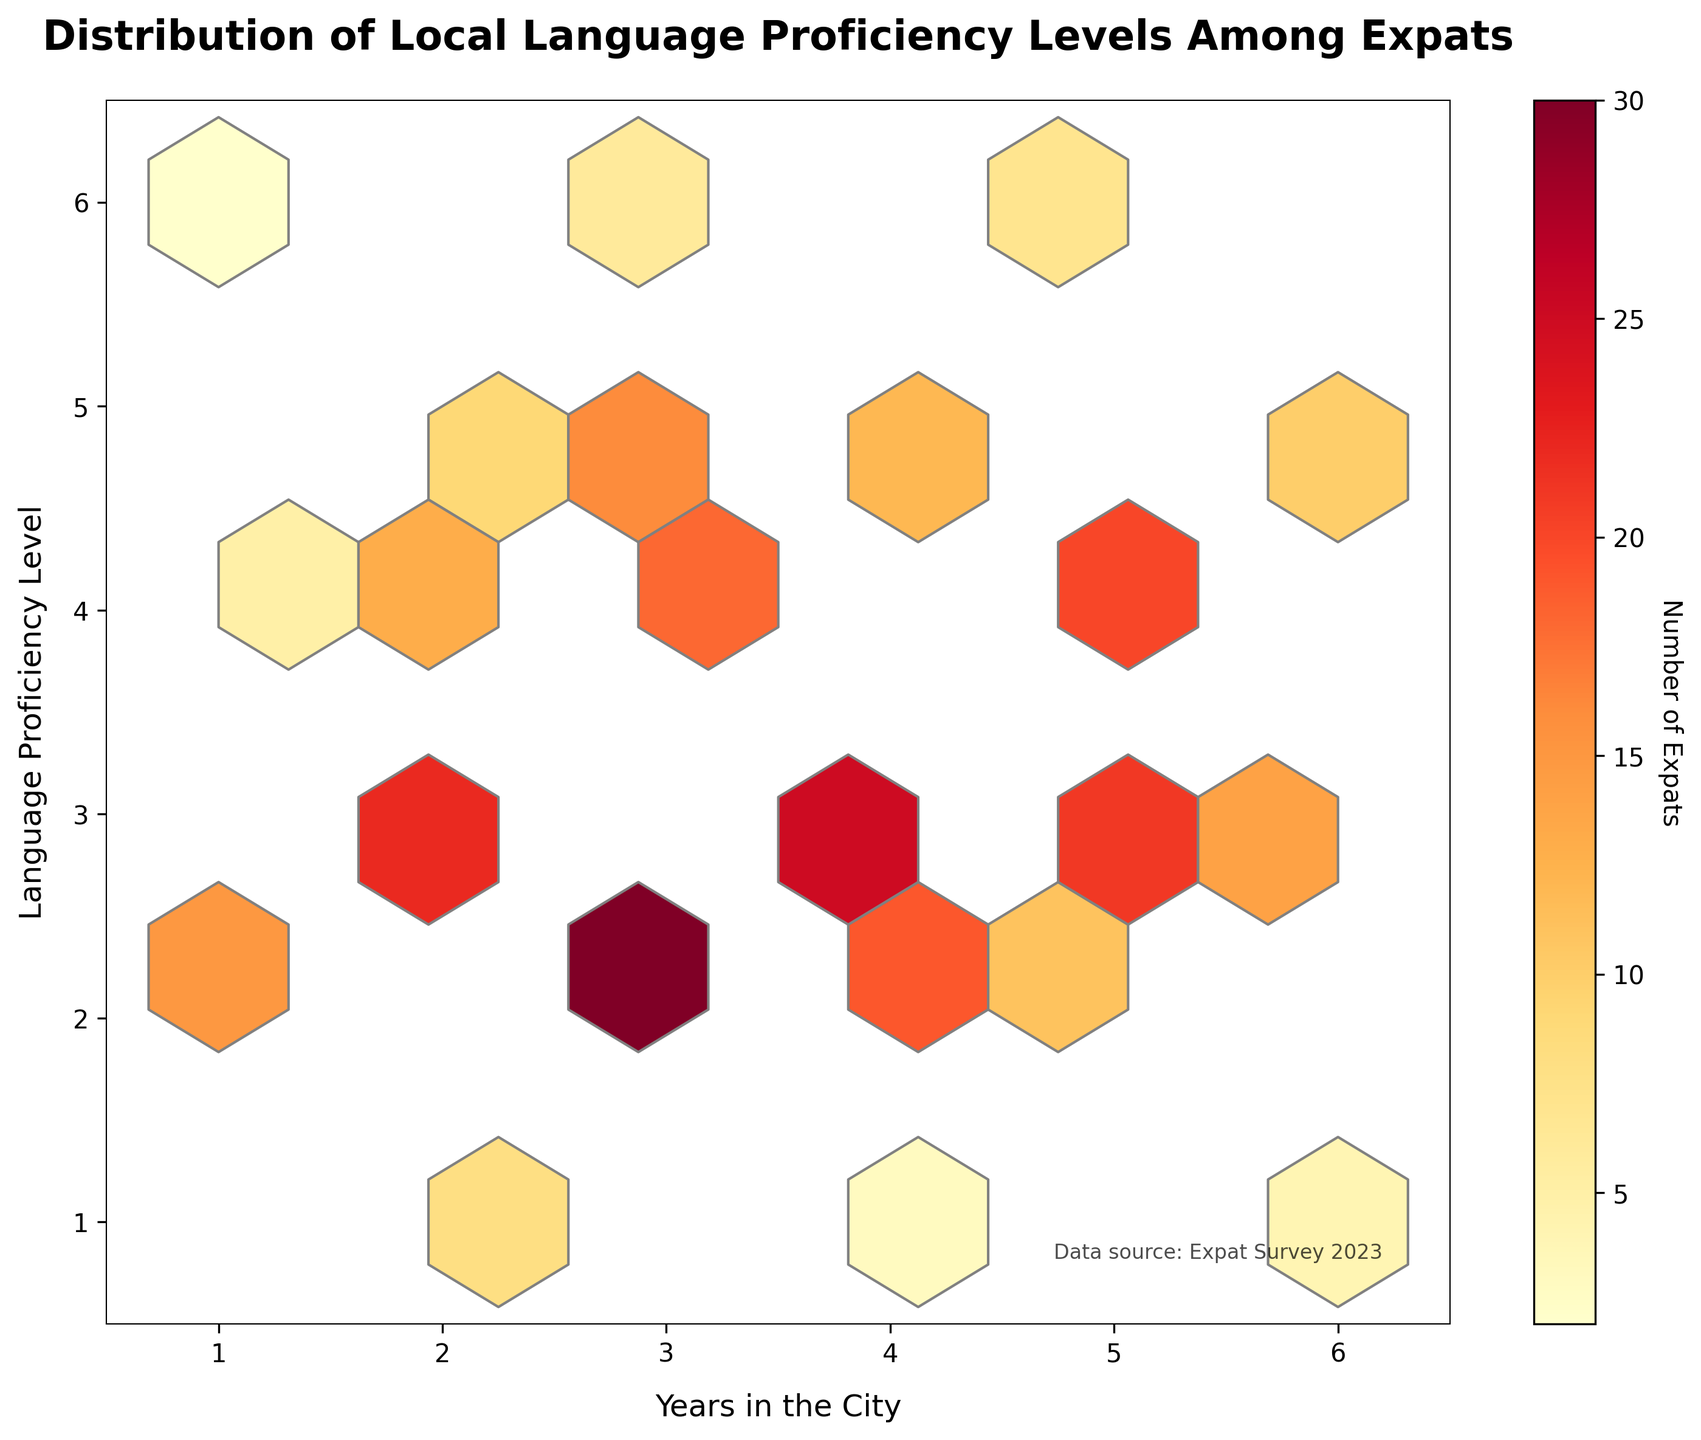What's the title of the plot? The plot title is provided at the top of the figure. It reads 'Distribution of Local Language Proficiency Levels Among Expats'
Answer: Distribution of Local Language Proficiency Levels Among Expats What does the color intensity on the hexagons represent? The color intensity on the hexagons represents the 'Number of Expats'. Darker shades indicate a higher number of expats.
Answer: Number of Expats Which range of 'Years in the City' has the highest concentration of expats with high proficiency levels in the local language? Concentration of expats with high proficiency levels can be found by looking at the upper section of the y-axis, particularly around 'Years in the City' value of 5, as it shows hexagons with higher color intensity in those areas.
Answer: 5 years What is the number of expats at 'Years in the City' of 3 and 'Language Proficiency Level' of 2? Looking at the hexagon for x=3 and y=2, we can see the color intensity and if labeled, it shows 30 expats.
Answer: 30 expats Compare the number of expats with 2 years in the city and a proficiency level of 3 to those with 4 years in the city and a proficiency level of 2. Which is higher? Comparing hexagons for (x=2, y=3) and (x=4, y=2), the hexagon for (x=2, y=3) shows 22 expats, and the hexagon for (x=4, y=2) shows 19 expats. So, (x=2, y=3) is higher.
Answer: 22 vs. 19, 22 is higher How many expats have 'Years in the City' 5 and 'Language Proficiency Level' 3? By locating the hexagon for x=5 and y=3, it shows 21 expats.
Answer: 21 expats Is there a visible trend between the number of years expats spend in the city and their language proficiency levels? Observing the overall distribution and color intensities, generally, expats with more years in the city tend to have higher proficiency levels, indicated by higher intensities in the upper right section.
Answer: Yes, higher proficiency with more years What is the 'Language Proficiency Level' for expats who have only been 1 year in the city, according to the highest concentration? By examining hexagons for x=1, the most prominent concentration is at y=2 with 15 expats.
Answer: Proficiency level 2 Are there more expats with proficiency levels lower than 3 or higher than 3? By summing up data points: Less than 3: (for 1,2,3 years) 15+8+30+3+11+4 = 71; More than 3: (for 4,5,6 years) 12+6+16+21+7+9+13+20+10 = 114; Hence, more expats have proficiency levels higher than 3.
Answer: Higher than 3 Compare the number of expats with 6 years in the city to those with 2 years in the city. Which group is larger? Sum of counts for x=6 is 2+14+10+4 = 30, and for x=2 is 8+22+9+13 = 52. Thus, 2-year expats are more.
Answer: 52 vs. 30, 2-year is larger 